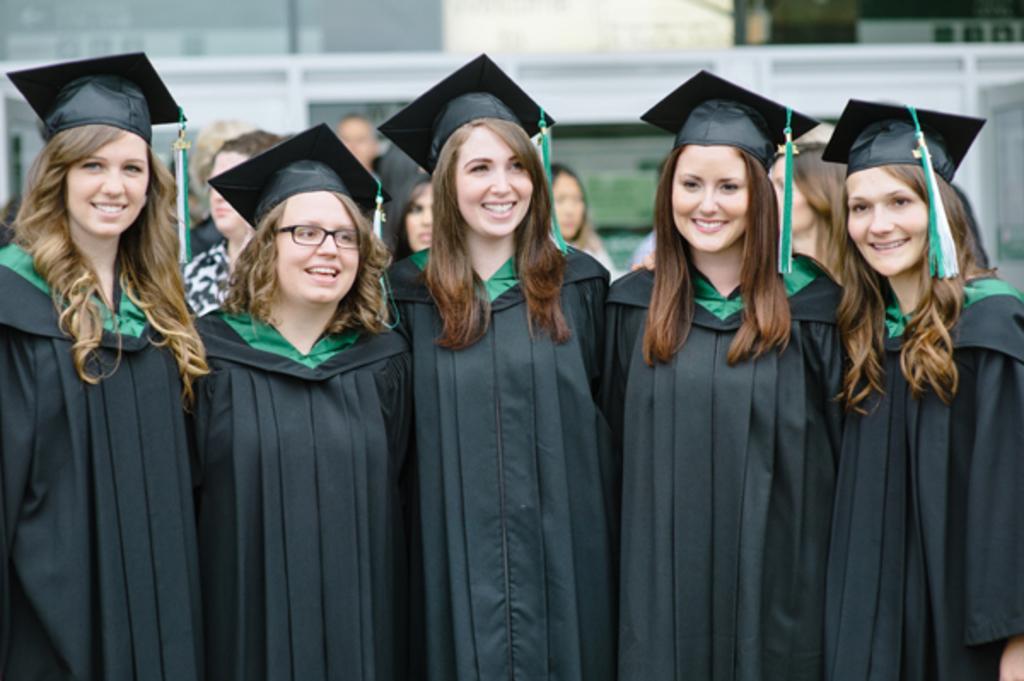Describe this image in one or two sentences. In this picture there are five women who are wearing the same dress and they are smiling. In the back i can see some people were standing. In the background i can see the building and plants. 